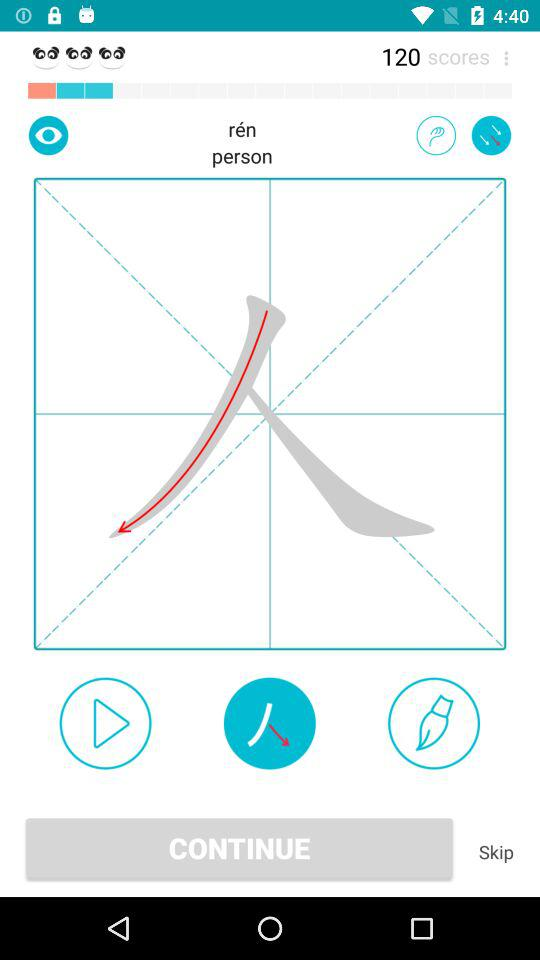How many strokes does this character take?
When the provided information is insufficient, respond with <no answer>. <no answer> 